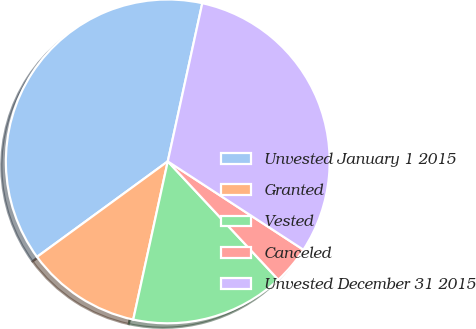Convert chart to OTSL. <chart><loc_0><loc_0><loc_500><loc_500><pie_chart><fcel>Unvested January 1 2015<fcel>Granted<fcel>Vested<fcel>Canceled<fcel>Unvested December 31 2015<nl><fcel>38.46%<fcel>11.54%<fcel>15.38%<fcel>3.85%<fcel>30.77%<nl></chart> 